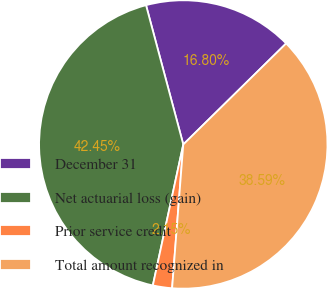<chart> <loc_0><loc_0><loc_500><loc_500><pie_chart><fcel>December 31<fcel>Net actuarial loss (gain)<fcel>Prior service credit<fcel>Total amount recognized in<nl><fcel>16.8%<fcel>42.45%<fcel>2.15%<fcel>38.59%<nl></chart> 